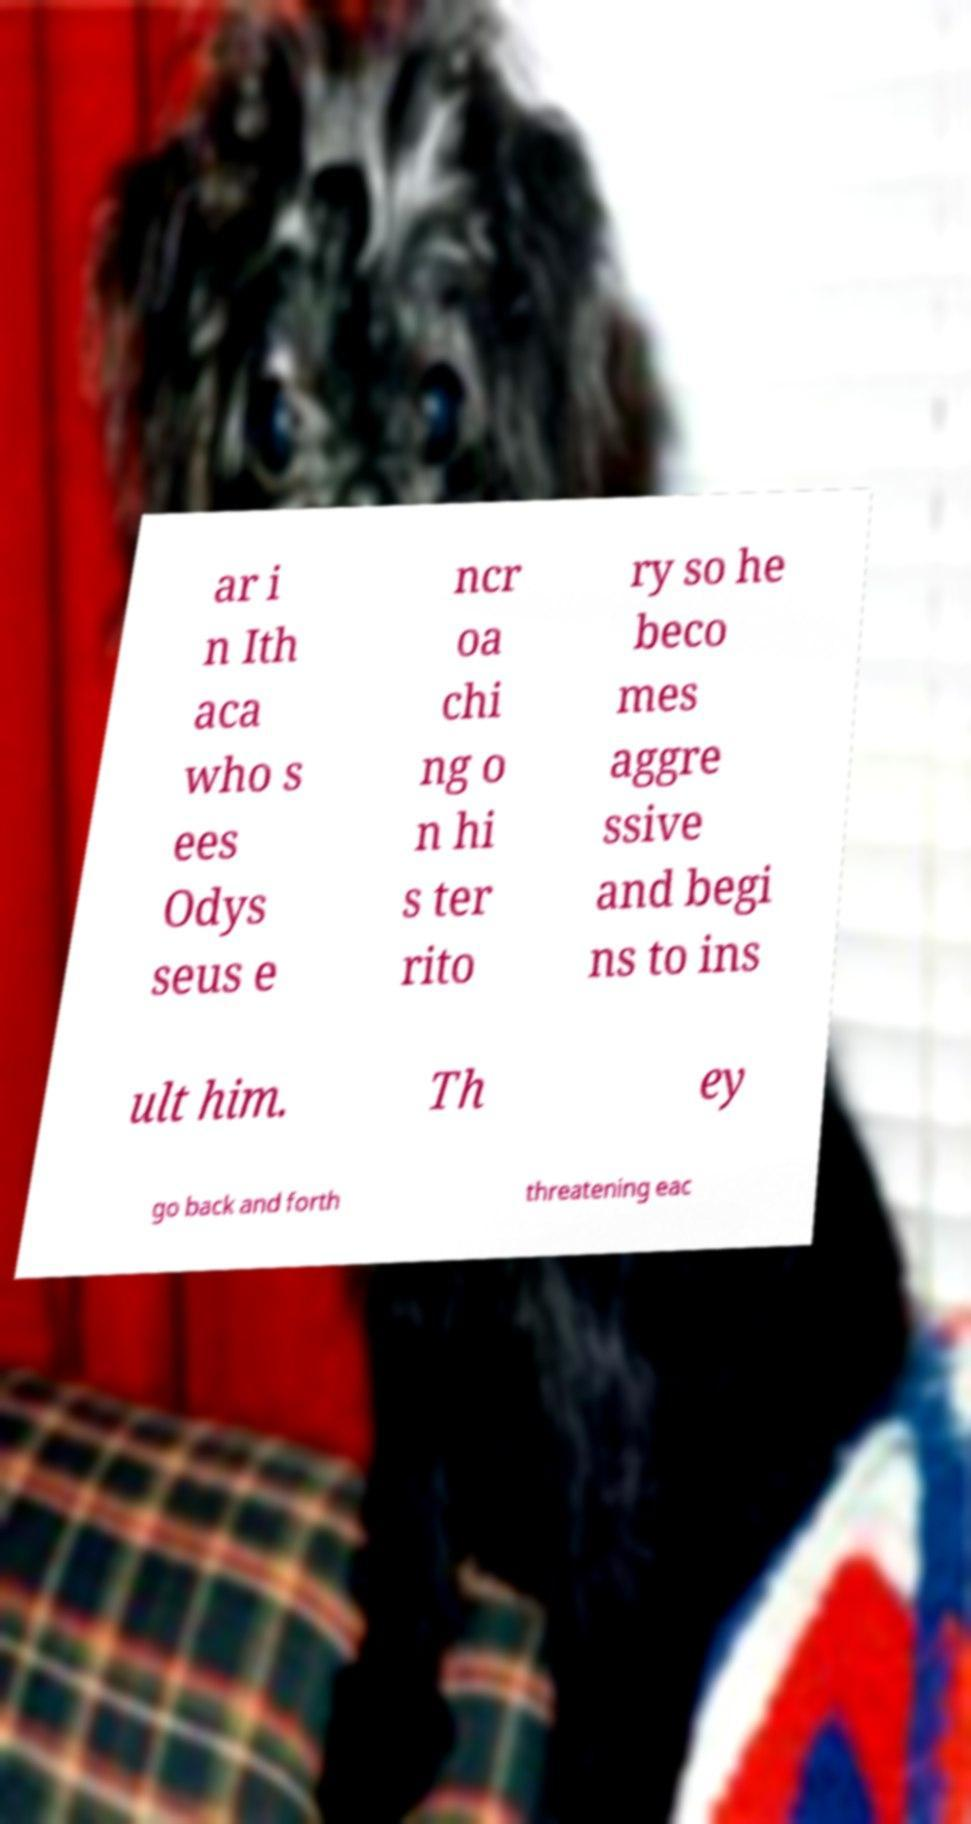Could you assist in decoding the text presented in this image and type it out clearly? ar i n Ith aca who s ees Odys seus e ncr oa chi ng o n hi s ter rito ry so he beco mes aggre ssive and begi ns to ins ult him. Th ey go back and forth threatening eac 